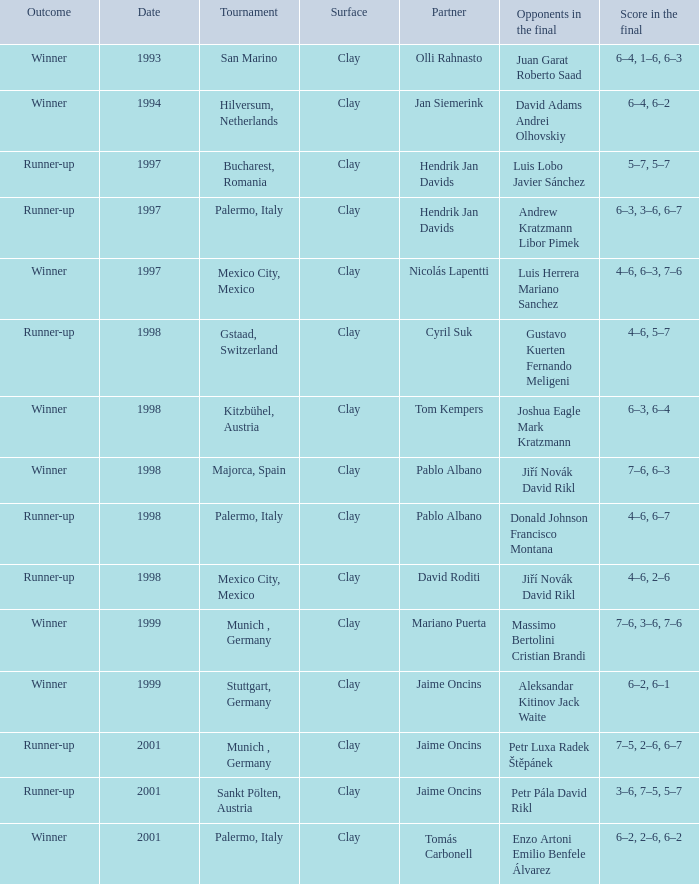Who are the Opponents in the final prior to 1998 in the Bucharest, Romania Tournament? Luis Lobo Javier Sánchez. 